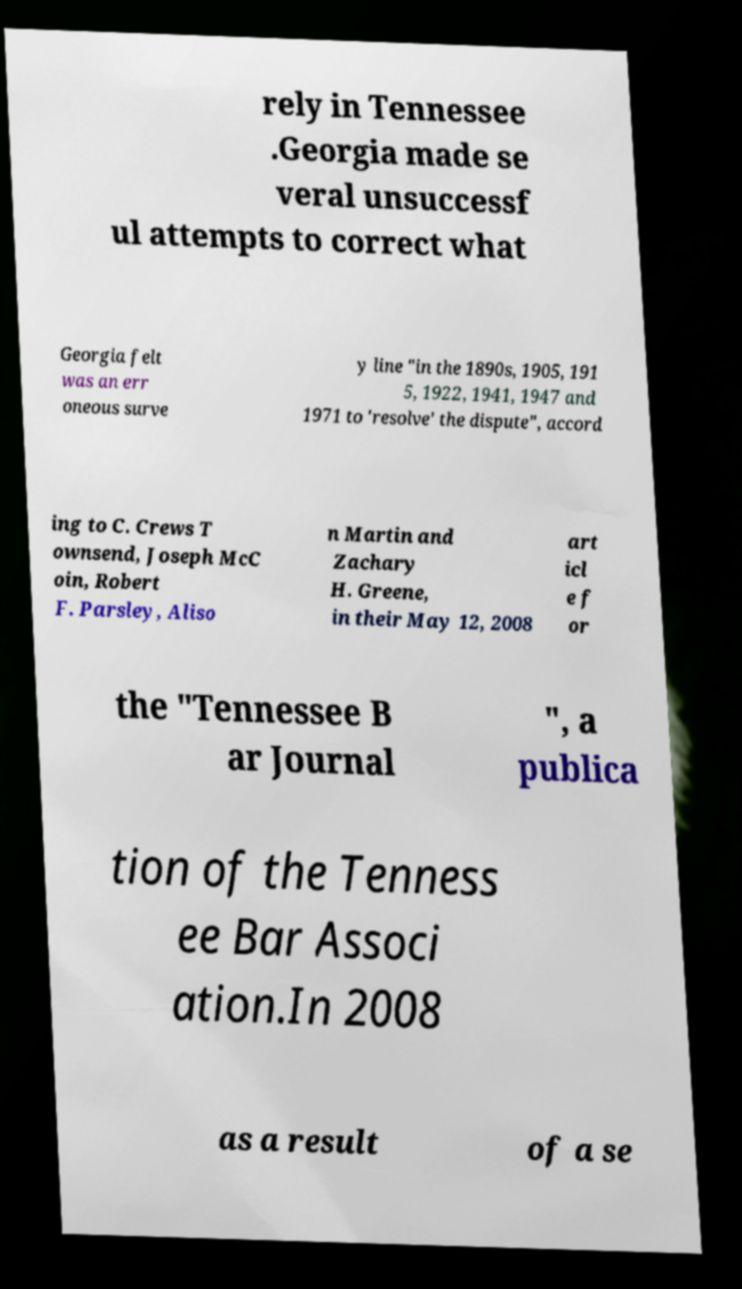Can you read and provide the text displayed in the image?This photo seems to have some interesting text. Can you extract and type it out for me? rely in Tennessee .Georgia made se veral unsuccessf ul attempts to correct what Georgia felt was an err oneous surve y line "in the 1890s, 1905, 191 5, 1922, 1941, 1947 and 1971 to 'resolve' the dispute", accord ing to C. Crews T ownsend, Joseph McC oin, Robert F. Parsley, Aliso n Martin and Zachary H. Greene, in their May 12, 2008 art icl e f or the "Tennessee B ar Journal ", a publica tion of the Tenness ee Bar Associ ation.In 2008 as a result of a se 